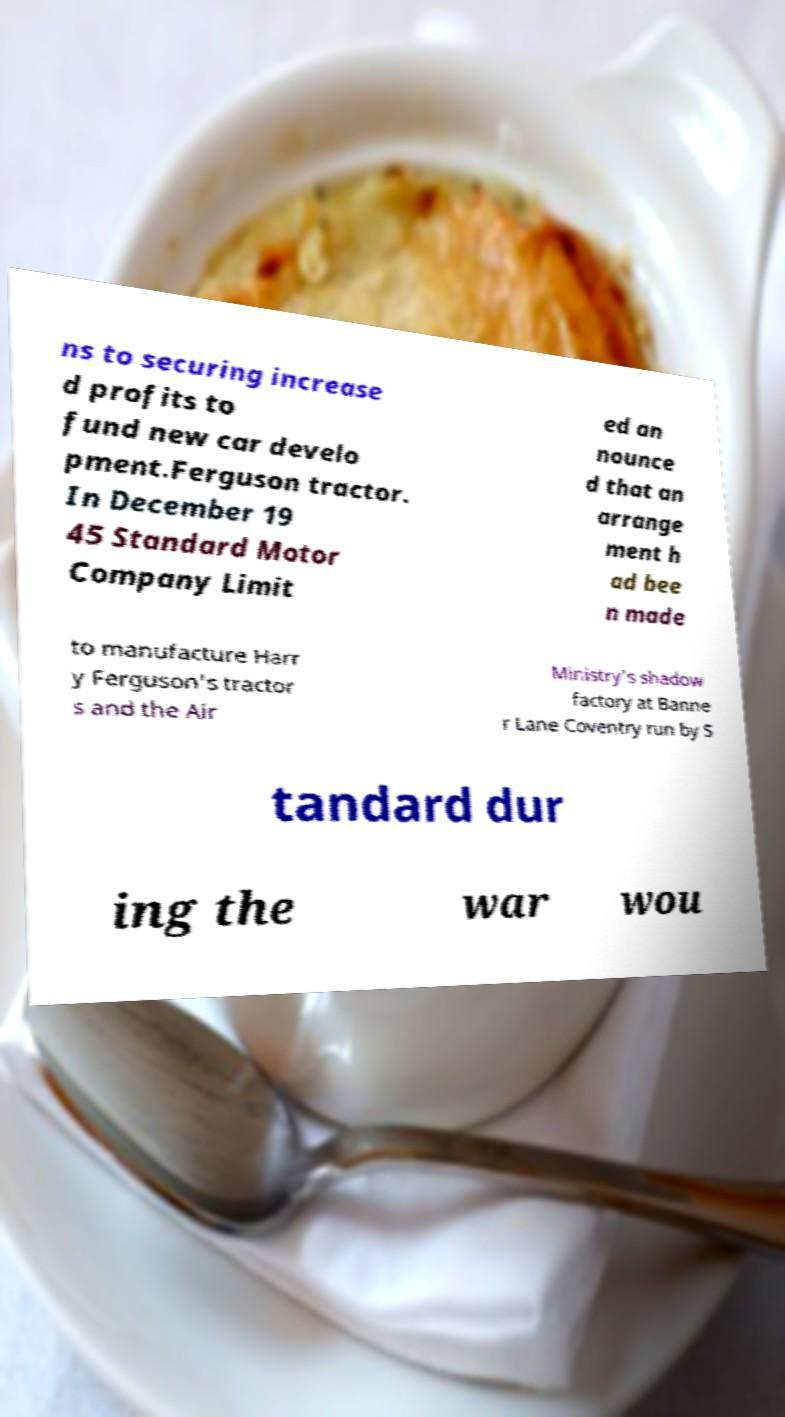Could you assist in decoding the text presented in this image and type it out clearly? ns to securing increase d profits to fund new car develo pment.Ferguson tractor. In December 19 45 Standard Motor Company Limit ed an nounce d that an arrange ment h ad bee n made to manufacture Harr y Ferguson's tractor s and the Air Ministry's shadow factory at Banne r Lane Coventry run by S tandard dur ing the war wou 